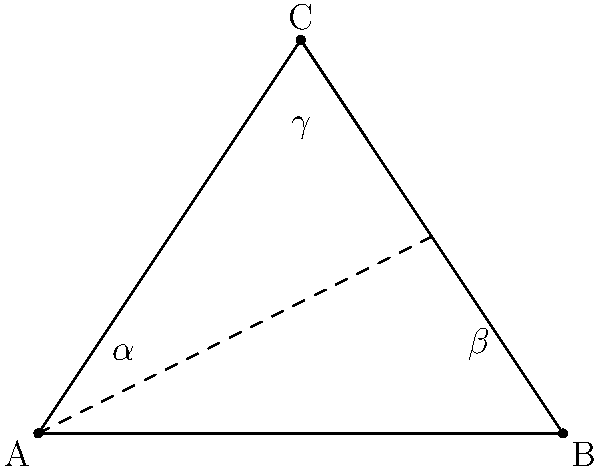In decoding a Xindi star chart, you encounter a triangular formation representing three celestial bodies. The angles of this triangle are labeled $\alpha$, $\beta$, and $\gamma$, as shown in the diagram. If $\alpha = 45°$ and $\beta = 60°$, what is the value of $\gamma$ in degrees? To solve this problem, we'll use the fundamental property of triangles that the sum of all interior angles is always 180°. Here's the step-by-step process:

1. Recall the triangle angle sum theorem: $\alpha + \beta + \gamma = 180°$

2. We are given two angles:
   $\alpha = 45°$
   $\beta = 60°$

3. Substitute these values into the equation:
   $45° + 60° + \gamma = 180°$

4. Simplify the left side:
   $105° + \gamma = 180°$

5. Subtract 105° from both sides:
   $\gamma = 180° - 105°$

6. Perform the subtraction:
   $\gamma = 75°$

Therefore, the value of angle $\gamma$ is 75°.
Answer: 75° 